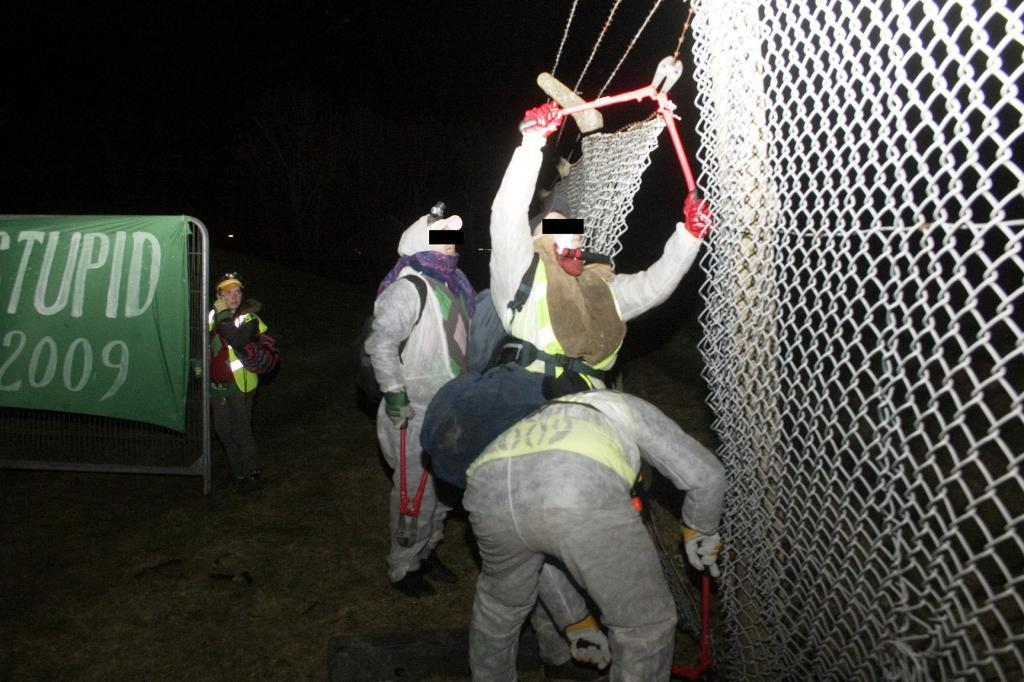What is happening in the image involving a group of people? The group of people are cutting a fence. What can be seen in the background of the image? There is a poster with text in the background. Is there anyone else present in the image besides the group of people cutting the fence? Yes, there is a person standing behind the poster. What type of seat is the guitar sitting on in the image? There is no guitar present in the image. What type of jeans is the person wearing behind the poster? The provided facts do not mention the clothing of the person standing behind the poster, so we cannot determine the type of jeans they are wearing. 